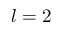<formula> <loc_0><loc_0><loc_500><loc_500>l = 2</formula> 